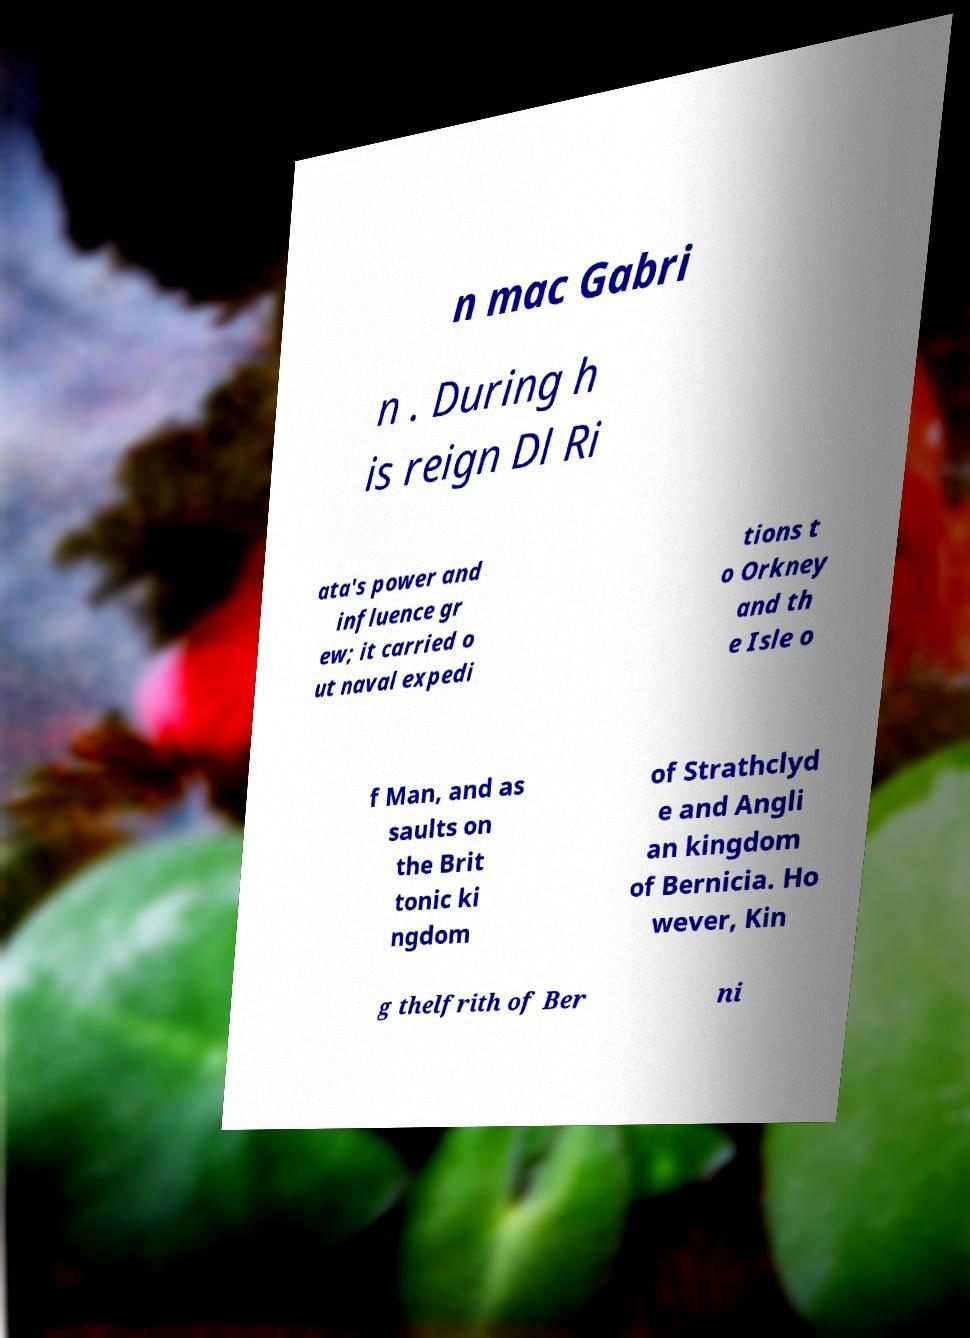Could you extract and type out the text from this image? n mac Gabri n . During h is reign Dl Ri ata's power and influence gr ew; it carried o ut naval expedi tions t o Orkney and th e Isle o f Man, and as saults on the Brit tonic ki ngdom of Strathclyd e and Angli an kingdom of Bernicia. Ho wever, Kin g thelfrith of Ber ni 